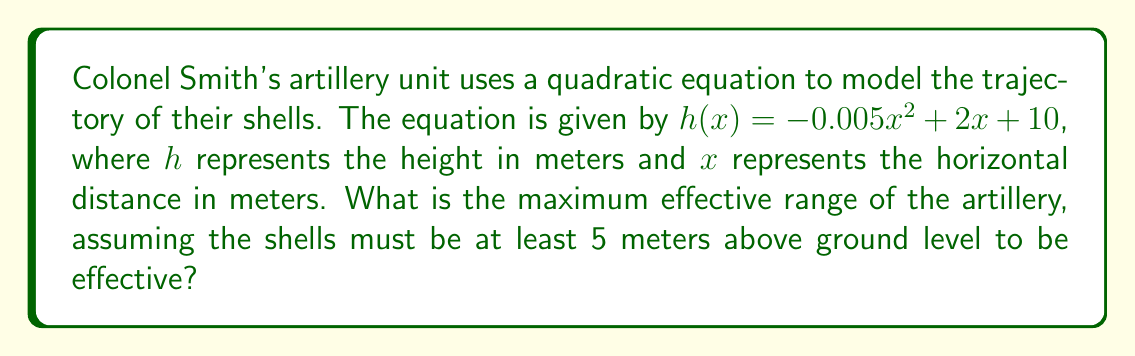Show me your answer to this math problem. To solve this problem, we need to follow these steps:

1) The quadratic equation given is $h(x) = -0.005x^2 + 2x + 10$

2) We need to find the points where the height is 5 meters. This means solving:
   $5 = -0.005x^2 + 2x + 10$

3) Rearrange the equation:
   $0 = -0.005x^2 + 2x + 5$

4) This is in the form $ax^2 + bx + c = 0$, where:
   $a = -0.005$
   $b = 2$
   $c = 5$

5) We can solve this using the quadratic formula: $x = \frac{-b \pm \sqrt{b^2 - 4ac}}{2a}$

6) Substituting our values:
   $x = \frac{-2 \pm \sqrt{2^2 - 4(-0.005)(5)}}{2(-0.005)}$

7) Simplify:
   $x = \frac{-2 \pm \sqrt{4 + 0.1}}{-0.01} = \frac{-2 \pm \sqrt{4.1}}{-0.01}$

8) Calculate:
   $x = \frac{-2 \pm 2.025}{-0.01} = 200 \pm 202.5$

9) This gives us two solutions:
   $x_1 = 200 + 202.5 = 402.5$
   $x_2 = 200 - 202.5 = -2.5$

10) Since we're dealing with distance, we ignore the negative solution.

Therefore, the maximum effective range is 402.5 meters.
Answer: 402.5 meters 